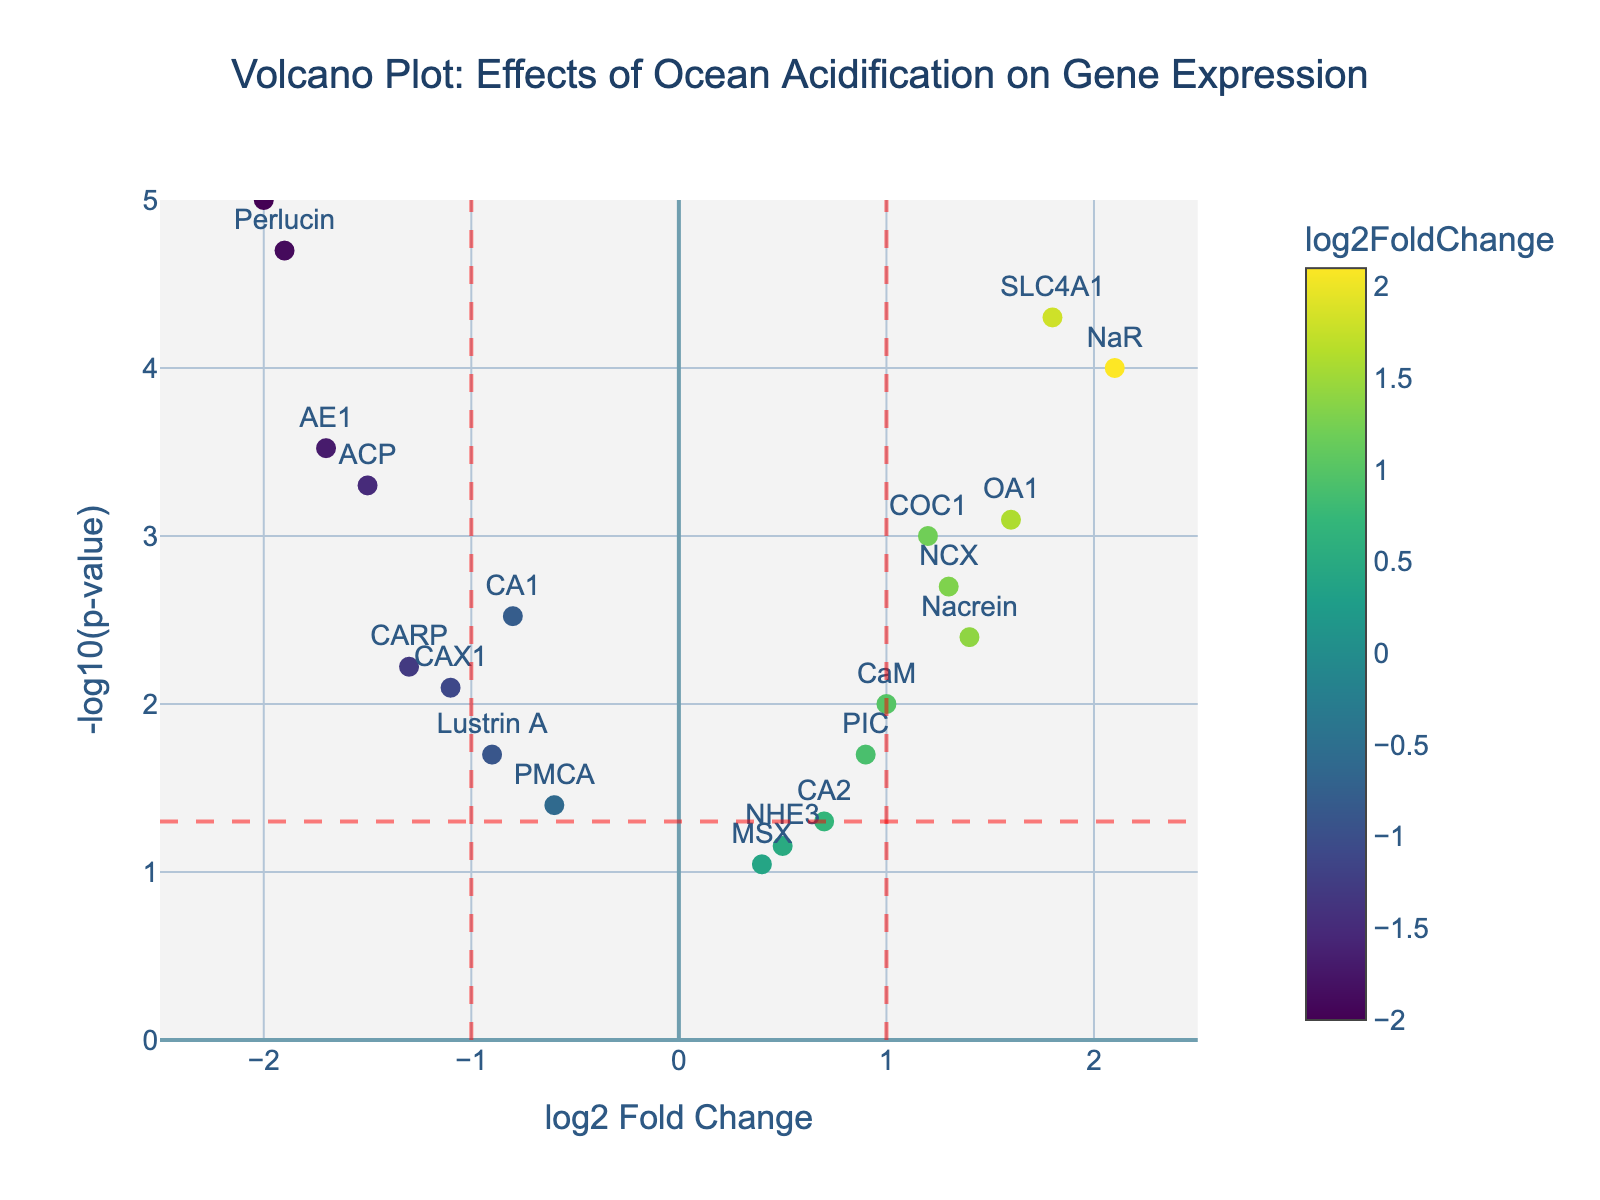What's the title of the plot? The title is usually found at the top center of the plot. Here, it states, "Volcano Plot: Effects of Ocean Acidification on Gene Expression."
Answer: Volcano Plot: Effects of Ocean Acidification on Gene Expression What are the names of the axes? The x-axis is labeled "log2 Fold Change," and the y-axis is labeled "-log10(p-value)."
Answer: log2 Fold Change, -log10(p-value) Which gene has the smallest p-value? To find the smallest p-value, locate the highest point on the y-axis since -log10(p-value) is high when p-value is low. Perlucin is the highest on the y-axis.
Answer: Perlucin What is the log2 fold change of the gene NaR? To find this, locate the gene "NaR" on the plot and check its position along the x-axis. The hovertext shows NaR with a log2 fold change of 2.1.
Answer: 2.1 How many genes have a log2 Fold Change greater than 1? To answer this, count the number of data points to the right of the vertical line at x=1. These genes are NaR, SLC4A1, OA1, and NCX. There are 4.
Answer: 4 Which gene has the largest negative log2 Fold Change? To find this, look for the leftmost data point (largest negative value) on the x-axis. The hovertext shows that V-ATPase is the furthest left with a log2 fold change of -2.0.
Answer: V-ATPase How many genes have a p-value less than 0.05? A p-value less than 0.05 corresponds to -log10(p-value) greater than approximately 1.3. Count the points above this threshold: COC1, CA1, ACP, NaR, CAX1, SLC4A1, NCX, AE1, V-ATPase, CARP, OA1, Perlucin, Nacrein. There are 13 such genes.
Answer: 13 Which gene shows the smallest significant log2 Fold Change (p < 0.05)? First, identify genes with a significant p-value (above the red horizontal line). Then, among these, find the point closest to the origin on the x-axis. CA2 has a log2 fold change of 0.7.
Answer: CA2 Which gene shows the largest positive log2 Fold Change and also has a significant p-value (p < 0.05)? Look for the rightmost data point above the red horizontal line. The hovertext shows that NaR fits this criteria with a log2 fold change of 2.1.
Answer: NaR How does the position of the gene COC1 compare to CA1 in terms of log2 Fold Change and p-value? Find COC1 and CA1 on the plot. COC1 is located further right and higher up than CA1, indicating a higher log2 fold change and a smaller p-value.
Answer: COC1 has higher log2 Fold Change and smaller p-value 